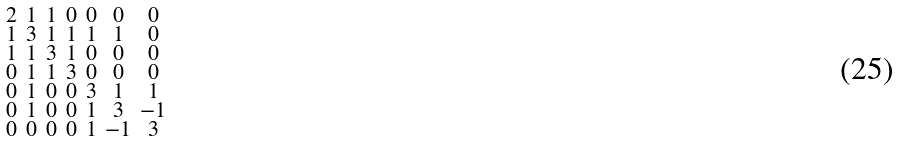Convert formula to latex. <formula><loc_0><loc_0><loc_500><loc_500>\begin{smallmatrix} 2 & 1 & 1 & 0 & 0 & 0 & 0 \\ 1 & 3 & 1 & 1 & 1 & 1 & 0 \\ 1 & 1 & 3 & 1 & 0 & 0 & 0 \\ 0 & 1 & 1 & 3 & 0 & 0 & 0 \\ 0 & 1 & 0 & 0 & 3 & 1 & 1 \\ 0 & 1 & 0 & 0 & 1 & 3 & - 1 \\ 0 & 0 & 0 & 0 & 1 & - 1 & 3 \end{smallmatrix}</formula> 